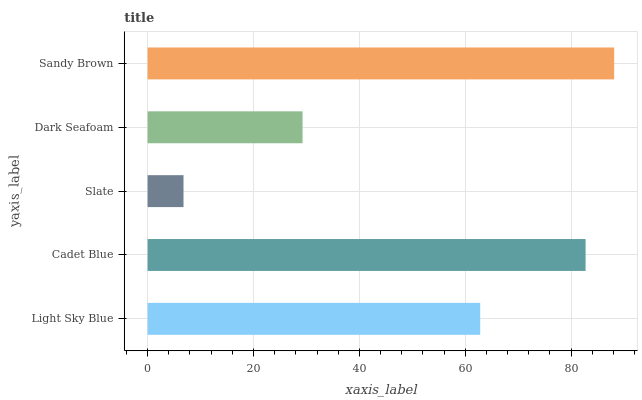Is Slate the minimum?
Answer yes or no. Yes. Is Sandy Brown the maximum?
Answer yes or no. Yes. Is Cadet Blue the minimum?
Answer yes or no. No. Is Cadet Blue the maximum?
Answer yes or no. No. Is Cadet Blue greater than Light Sky Blue?
Answer yes or no. Yes. Is Light Sky Blue less than Cadet Blue?
Answer yes or no. Yes. Is Light Sky Blue greater than Cadet Blue?
Answer yes or no. No. Is Cadet Blue less than Light Sky Blue?
Answer yes or no. No. Is Light Sky Blue the high median?
Answer yes or no. Yes. Is Light Sky Blue the low median?
Answer yes or no. Yes. Is Cadet Blue the high median?
Answer yes or no. No. Is Sandy Brown the low median?
Answer yes or no. No. 